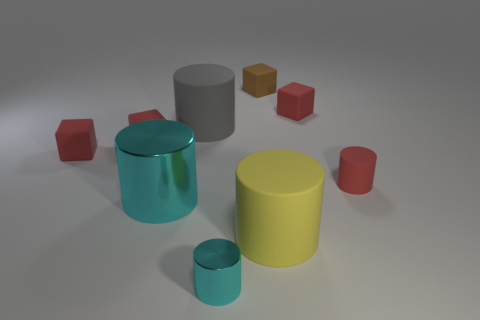Subtract all red blocks. How many were subtracted if there are1red blocks left? 2 Subtract all cyan cylinders. How many cylinders are left? 3 Subtract all gray cubes. How many cyan cylinders are left? 2 Subtract 1 blocks. How many blocks are left? 3 Subtract all yellow cylinders. How many cylinders are left? 4 Add 1 large brown spheres. How many objects exist? 10 Subtract all cylinders. How many objects are left? 4 Subtract all blue blocks. Subtract all yellow spheres. How many blocks are left? 4 Subtract all red rubber things. Subtract all gray matte things. How many objects are left? 4 Add 4 brown rubber blocks. How many brown rubber blocks are left? 5 